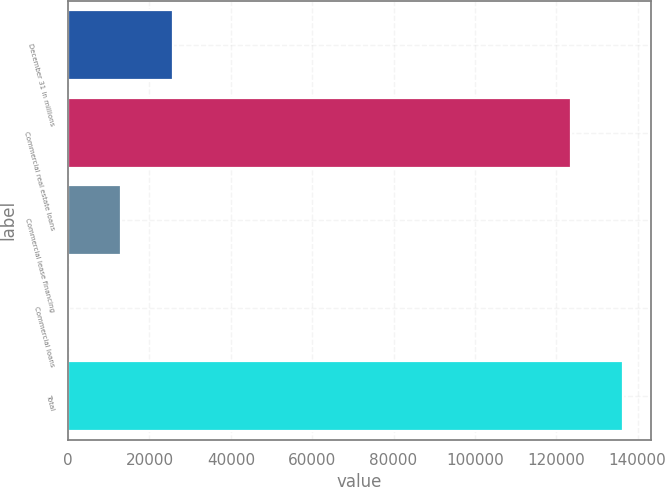Convert chart. <chart><loc_0><loc_0><loc_500><loc_500><bar_chart><fcel>December 31 in millions<fcel>Commercial real estate loans<fcel>Commercial lease financing<fcel>Commercial loans<fcel>Total<nl><fcel>25858.6<fcel>123599<fcel>13052.8<fcel>247<fcel>136405<nl></chart> 